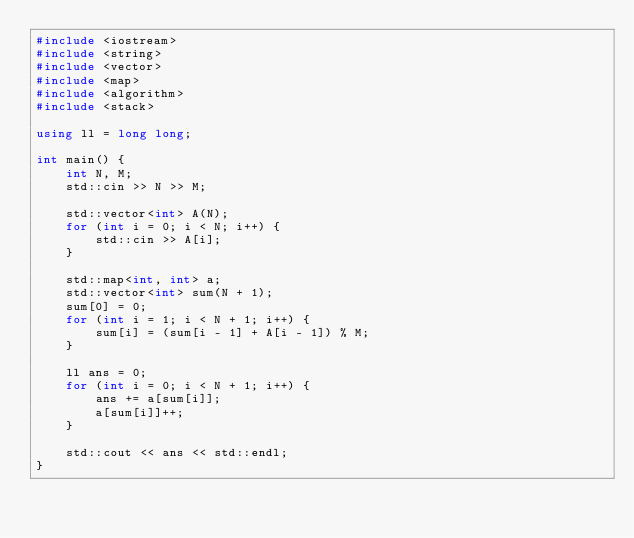<code> <loc_0><loc_0><loc_500><loc_500><_C++_>#include <iostream>
#include <string>
#include <vector>
#include <map>
#include <algorithm>
#include <stack>

using ll = long long;

int main() {
    int N, M;
    std::cin >> N >> M;

    std::vector<int> A(N);
    for (int i = 0; i < N; i++) {
        std::cin >> A[i];
    }

    std::map<int, int> a;
    std::vector<int> sum(N + 1);
    sum[0] = 0;
    for (int i = 1; i < N + 1; i++) {
        sum[i] = (sum[i - 1] + A[i - 1]) % M;
    }

    ll ans = 0;
    for (int i = 0; i < N + 1; i++) {
        ans += a[sum[i]];
        a[sum[i]]++;
    }

    std::cout << ans << std::endl;
}
</code> 